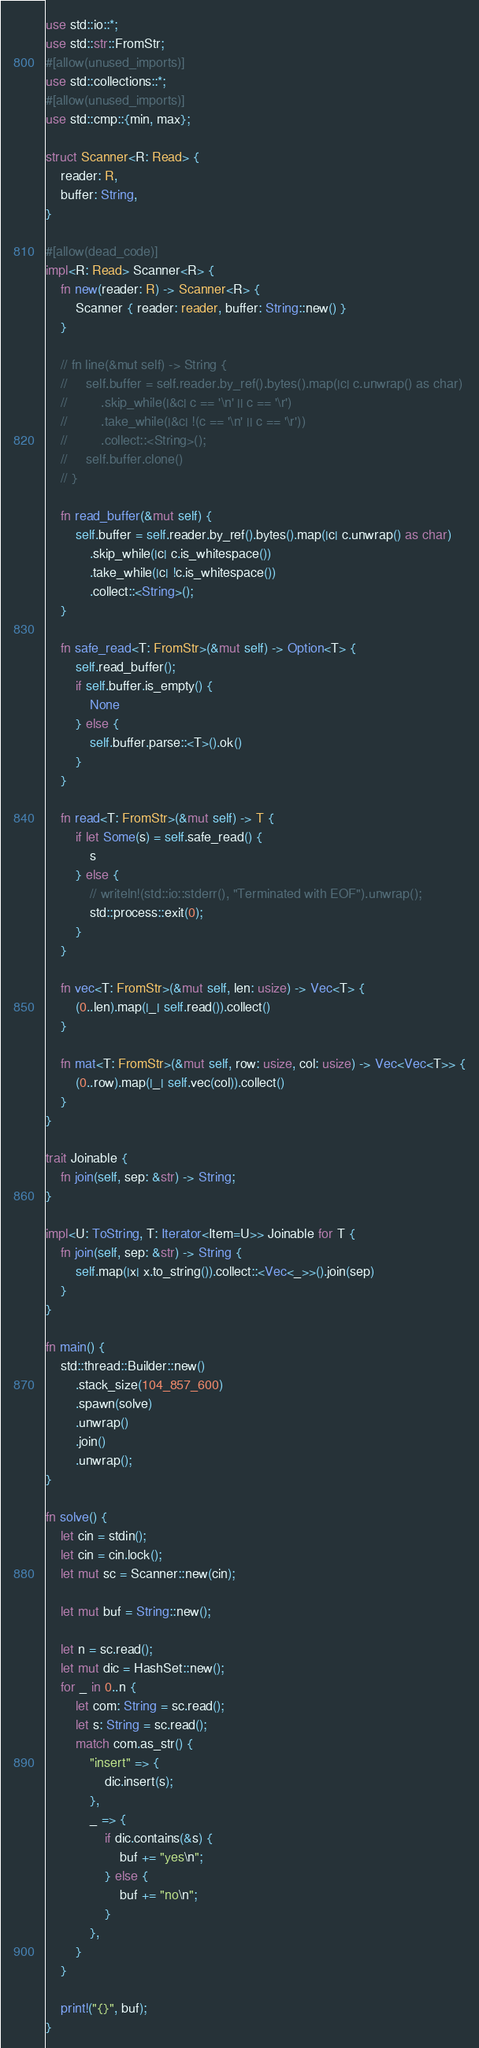<code> <loc_0><loc_0><loc_500><loc_500><_Rust_>use std::io::*;
use std::str::FromStr;
#[allow(unused_imports)]
use std::collections::*;
#[allow(unused_imports)]
use std::cmp::{min, max};

struct Scanner<R: Read> {
    reader: R,
    buffer: String,
}

#[allow(dead_code)]
impl<R: Read> Scanner<R> {
    fn new(reader: R) -> Scanner<R> {
        Scanner { reader: reader, buffer: String::new() }
    }

    // fn line(&mut self) -> String {
    //     self.buffer = self.reader.by_ref().bytes().map(|c| c.unwrap() as char)
    //         .skip_while(|&c| c == '\n' || c == '\r')
    //         .take_while(|&c| !(c == '\n' || c == '\r'))
    //         .collect::<String>();
    //     self.buffer.clone()
    // }

    fn read_buffer(&mut self) {
        self.buffer = self.reader.by_ref().bytes().map(|c| c.unwrap() as char)
            .skip_while(|c| c.is_whitespace())
            .take_while(|c| !c.is_whitespace())
            .collect::<String>();
    }

    fn safe_read<T: FromStr>(&mut self) -> Option<T> {
        self.read_buffer();
        if self.buffer.is_empty() {
            None
        } else {
            self.buffer.parse::<T>().ok()
        }
    }

    fn read<T: FromStr>(&mut self) -> T {
        if let Some(s) = self.safe_read() {
            s
        } else {
            // writeln!(std::io::stderr(), "Terminated with EOF").unwrap();
            std::process::exit(0);
        }
    }

    fn vec<T: FromStr>(&mut self, len: usize) -> Vec<T> {
        (0..len).map(|_| self.read()).collect()
    }

    fn mat<T: FromStr>(&mut self, row: usize, col: usize) -> Vec<Vec<T>> {
        (0..row).map(|_| self.vec(col)).collect()
    }
}

trait Joinable {
    fn join(self, sep: &str) -> String;
}

impl<U: ToString, T: Iterator<Item=U>> Joinable for T {
    fn join(self, sep: &str) -> String {
        self.map(|x| x.to_string()).collect::<Vec<_>>().join(sep)
    }
}

fn main() {
    std::thread::Builder::new()
        .stack_size(104_857_600)
        .spawn(solve)
        .unwrap()
        .join()
        .unwrap();
}

fn solve() {
    let cin = stdin();
    let cin = cin.lock();
    let mut sc = Scanner::new(cin);

    let mut buf = String::new();
    
    let n = sc.read();
    let mut dic = HashSet::new();
    for _ in 0..n {
        let com: String = sc.read();
        let s: String = sc.read();
        match com.as_str() {
            "insert" => {
                dic.insert(s);
            },
            _ => {
                if dic.contains(&s) {
                    buf += "yes\n";
                } else {
                    buf += "no\n";
                }
            },
        }
    }

    print!("{}", buf);
}

</code> 